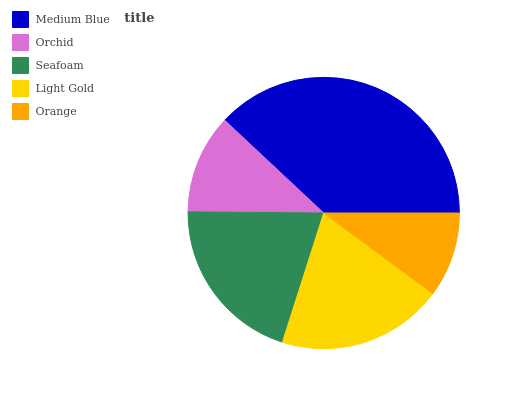Is Orange the minimum?
Answer yes or no. Yes. Is Medium Blue the maximum?
Answer yes or no. Yes. Is Orchid the minimum?
Answer yes or no. No. Is Orchid the maximum?
Answer yes or no. No. Is Medium Blue greater than Orchid?
Answer yes or no. Yes. Is Orchid less than Medium Blue?
Answer yes or no. Yes. Is Orchid greater than Medium Blue?
Answer yes or no. No. Is Medium Blue less than Orchid?
Answer yes or no. No. Is Light Gold the high median?
Answer yes or no. Yes. Is Light Gold the low median?
Answer yes or no. Yes. Is Medium Blue the high median?
Answer yes or no. No. Is Seafoam the low median?
Answer yes or no. No. 